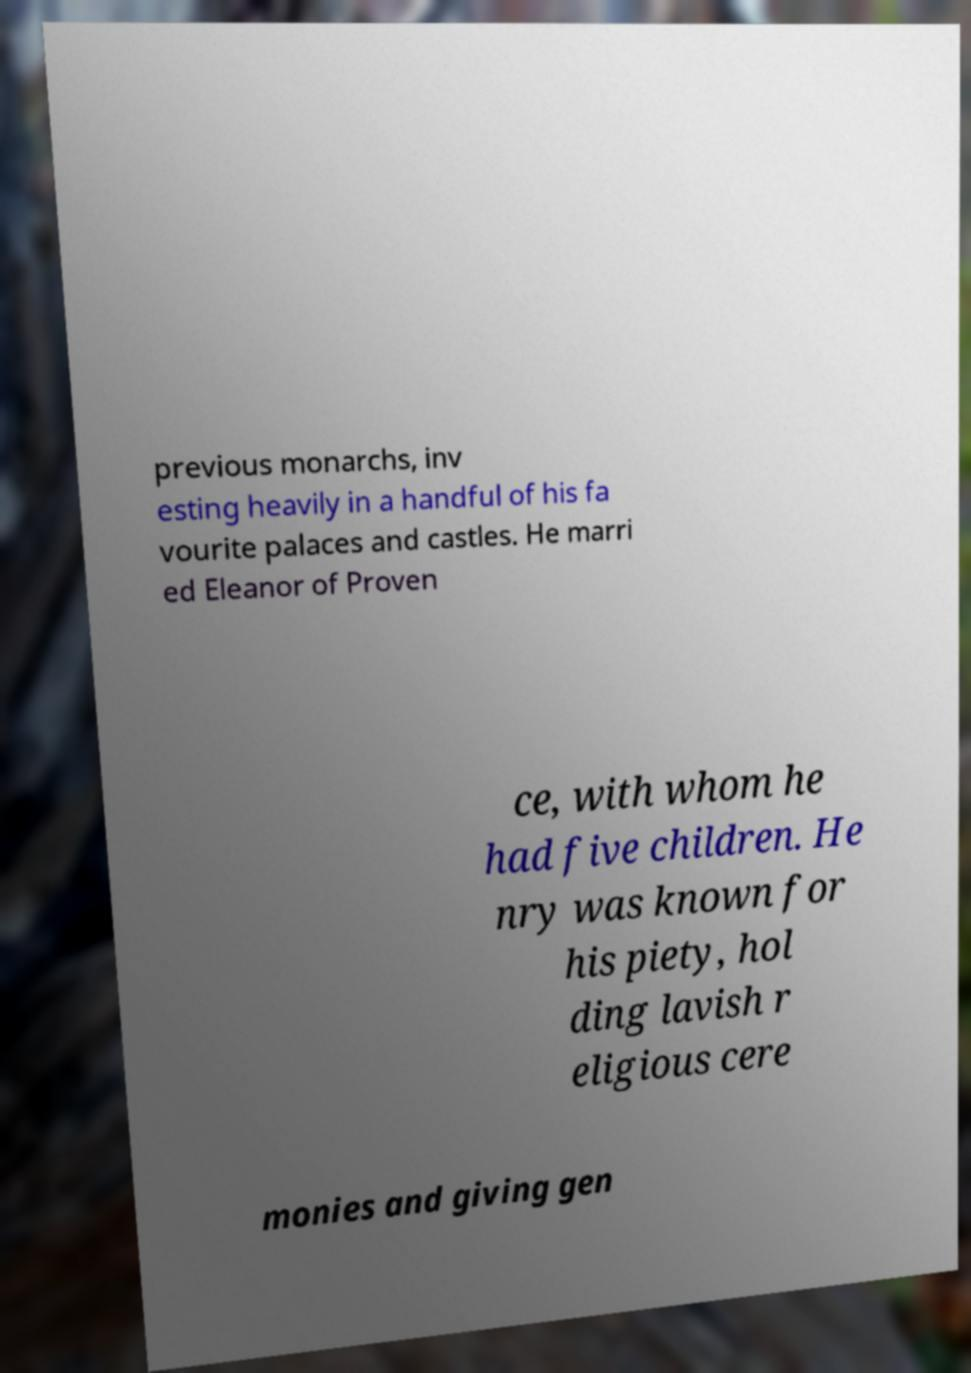Could you extract and type out the text from this image? previous monarchs, inv esting heavily in a handful of his fa vourite palaces and castles. He marri ed Eleanor of Proven ce, with whom he had five children. He nry was known for his piety, hol ding lavish r eligious cere monies and giving gen 